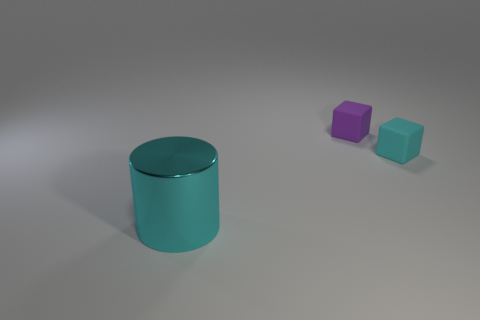Is there anything in the image that suggests a specific use or function for the objects? Without additional context or scale, it is challenging to ascribe specific uses or functions to the objects. Their simple geometric shapes - cubes and a cylinder - are typical in educational tools for teaching shapes and colors or in artistic compositions to explore form and spatial relationships. Their lack of identifiable features or markings makes it difficult to determine any intended use beyond theoretical or illustrative purposes. 